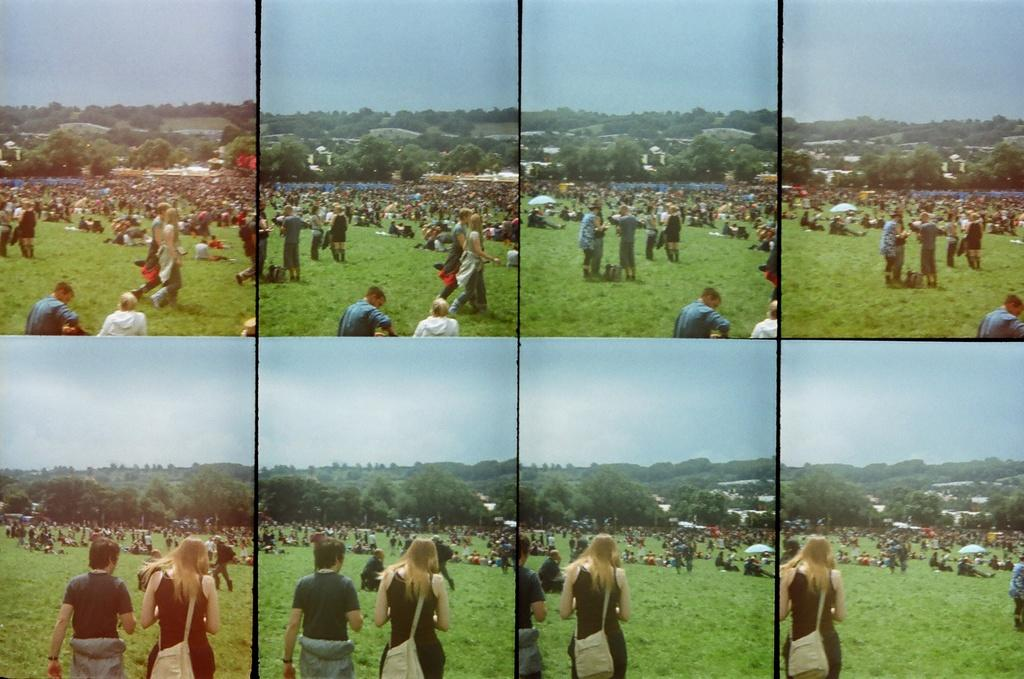What type of artwork is the image? The image is a collage. Can you describe the subjects in the image? There is a group of people in the image. What type of natural environment is depicted in the image? There is grass and trees in the image. What type of structures are present in the image? There are houses in the image. What objects are used for protection from the sun or rain in the image? There are umbrellas in the image. What part of the natural environment is visible in the image? The sky is visible in the image. What type of tool is being used to fix the cabbage in the image? There is no tool or cabbage present in the image. What type of animal is shown with a tail in the image? There are no animals with tails depicted in the image. 